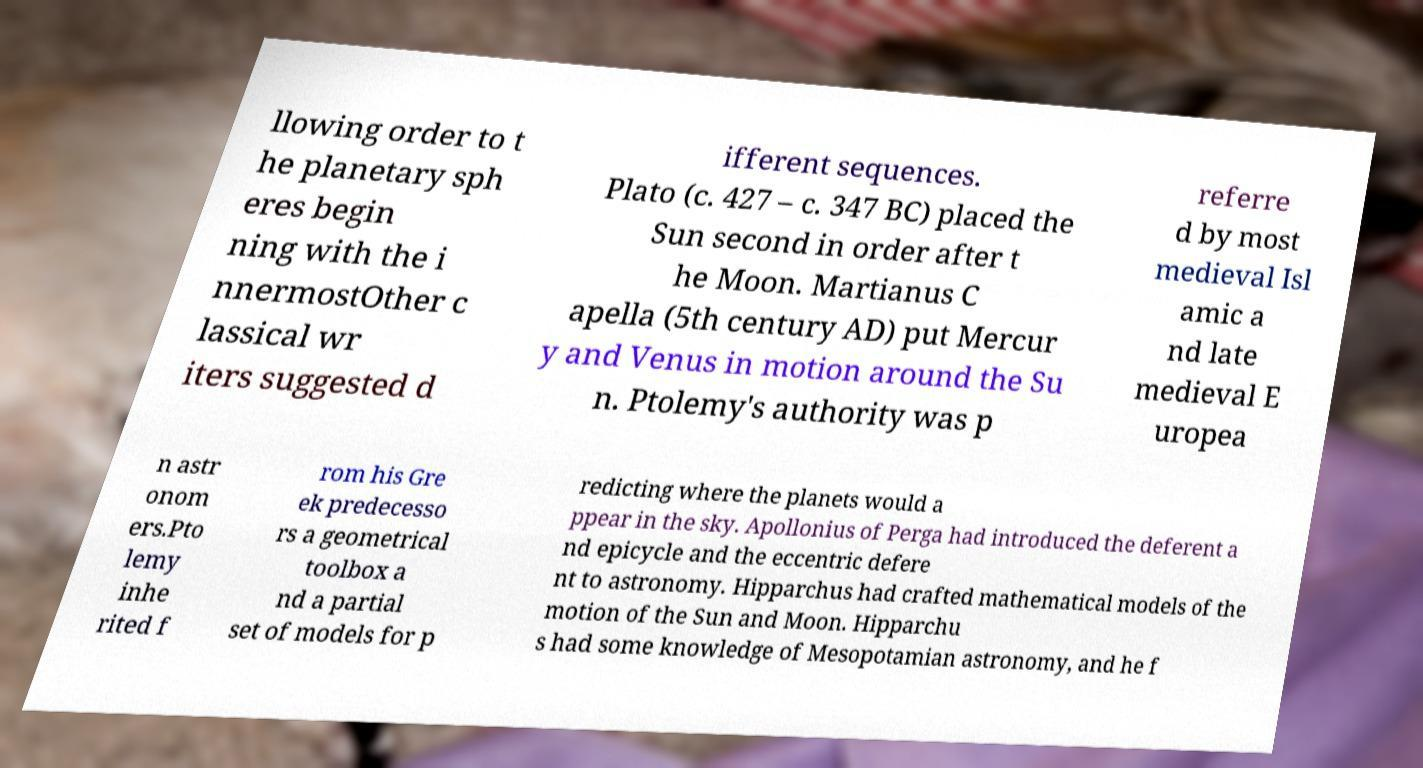Can you accurately transcribe the text from the provided image for me? llowing order to t he planetary sph eres begin ning with the i nnermostOther c lassical wr iters suggested d ifferent sequences. Plato (c. 427 – c. 347 BC) placed the Sun second in order after t he Moon. Martianus C apella (5th century AD) put Mercur y and Venus in motion around the Su n. Ptolemy's authority was p referre d by most medieval Isl amic a nd late medieval E uropea n astr onom ers.Pto lemy inhe rited f rom his Gre ek predecesso rs a geometrical toolbox a nd a partial set of models for p redicting where the planets would a ppear in the sky. Apollonius of Perga had introduced the deferent a nd epicycle and the eccentric defere nt to astronomy. Hipparchus had crafted mathematical models of the motion of the Sun and Moon. Hipparchu s had some knowledge of Mesopotamian astronomy, and he f 